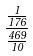<formula> <loc_0><loc_0><loc_500><loc_500>\frac { \frac { 1 } { 1 7 6 } } { \frac { 4 6 9 } { 1 0 } }</formula> 